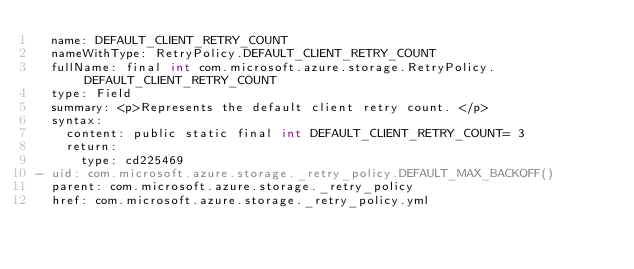Convert code to text. <code><loc_0><loc_0><loc_500><loc_500><_YAML_>  name: DEFAULT_CLIENT_RETRY_COUNT
  nameWithType: RetryPolicy.DEFAULT_CLIENT_RETRY_COUNT
  fullName: final int com.microsoft.azure.storage.RetryPolicy.DEFAULT_CLIENT_RETRY_COUNT
  type: Field
  summary: <p>Represents the default client retry count. </p>
  syntax:
    content: public static final int DEFAULT_CLIENT_RETRY_COUNT= 3
    return:
      type: cd225469
- uid: com.microsoft.azure.storage._retry_policy.DEFAULT_MAX_BACKOFF()
  parent: com.microsoft.azure.storage._retry_policy
  href: com.microsoft.azure.storage._retry_policy.yml</code> 